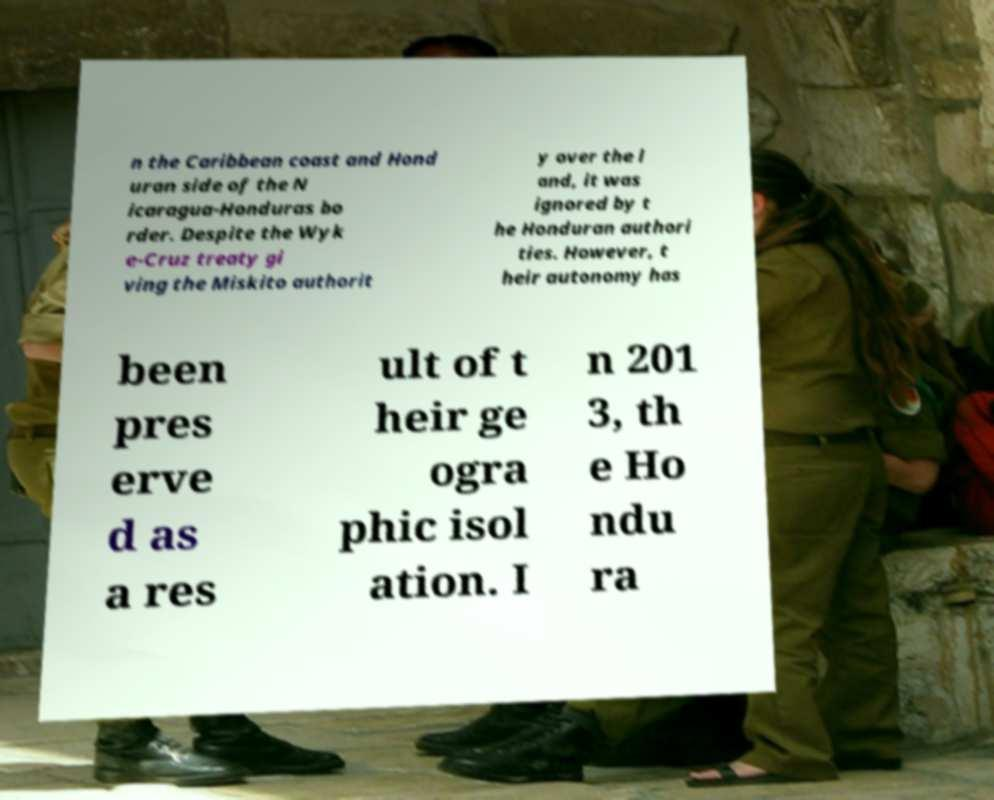Could you assist in decoding the text presented in this image and type it out clearly? n the Caribbean coast and Hond uran side of the N icaragua-Honduras bo rder. Despite the Wyk e-Cruz treaty gi ving the Miskito authorit y over the l and, it was ignored by t he Honduran authori ties. However, t heir autonomy has been pres erve d as a res ult of t heir ge ogra phic isol ation. I n 201 3, th e Ho ndu ra 